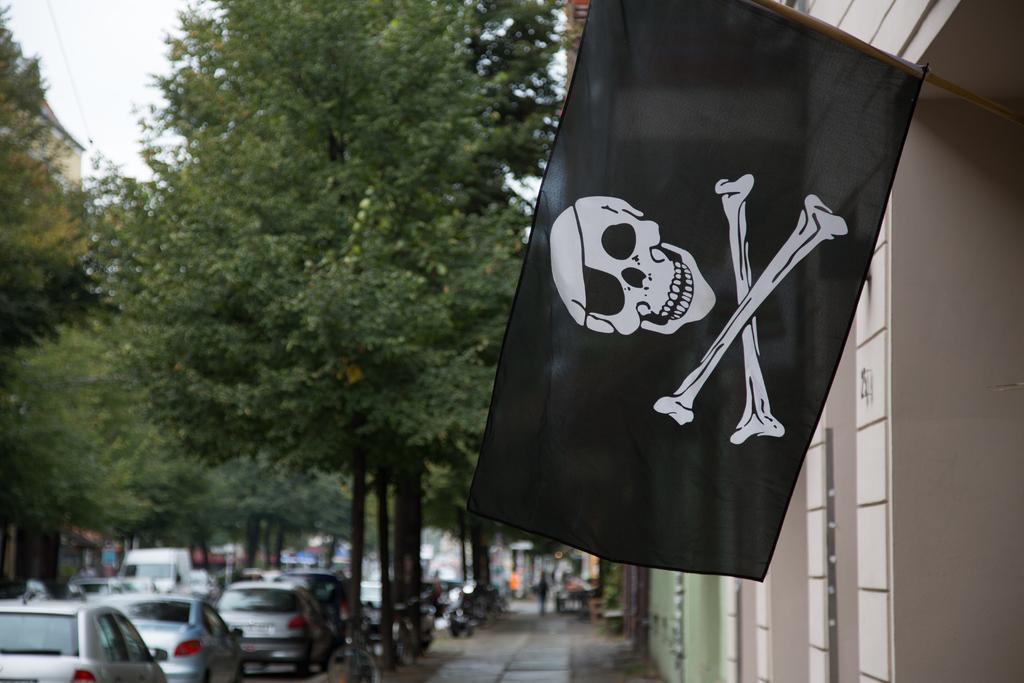Can you describe this image briefly? In the picture we can see some buildings to it, we can see a black color flag with a skeleton image on it and beside it, we can see a path with trees and beside it, we can see some vehicles are parked and on the opposite side of the vehicles also we can see some vehicles are parked near the buildings and in the background we can see trees and houses and on the top of the trees we can see a part of the sky. 